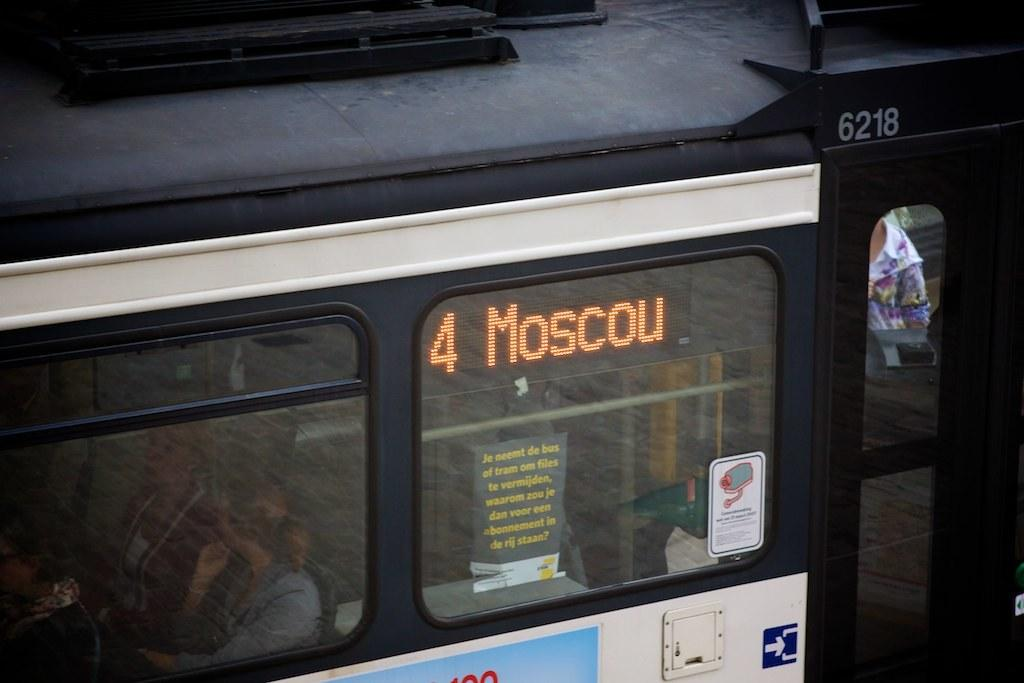Provide a one-sentence caption for the provided image. A bus in Russia that is on route 4 going to Moscow. 